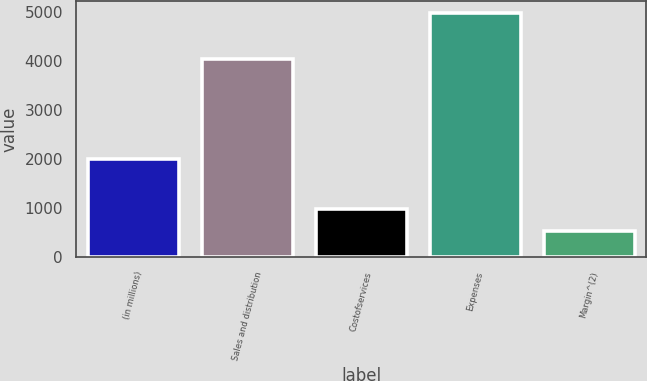Convert chart. <chart><loc_0><loc_0><loc_500><loc_500><bar_chart><fcel>(in millions)<fcel>Sales and distribution<fcel>Costofservices<fcel>Expenses<fcel>Margin^(2)<nl><fcel>2008<fcel>4040<fcel>983.3<fcel>4973<fcel>540<nl></chart> 